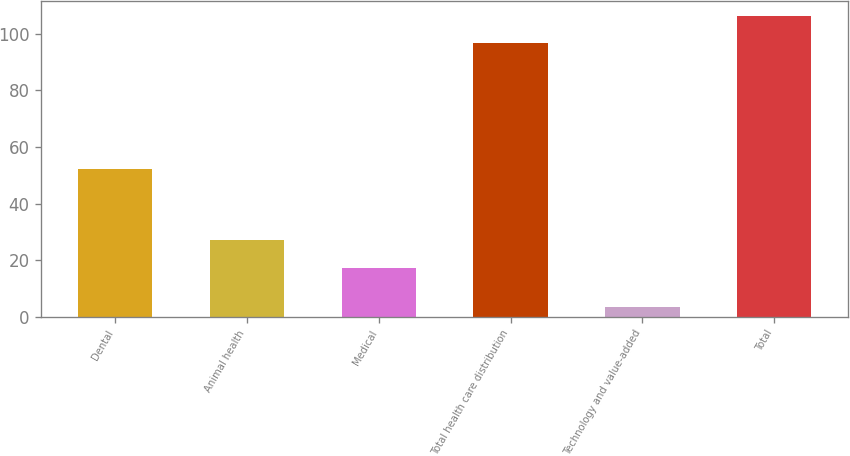<chart> <loc_0><loc_0><loc_500><loc_500><bar_chart><fcel>Dental<fcel>Animal health<fcel>Medical<fcel>Total health care distribution<fcel>Technology and value-added<fcel>Total<nl><fcel>52.3<fcel>27.2<fcel>17.2<fcel>96.7<fcel>3.3<fcel>106.37<nl></chart> 